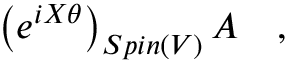Convert formula to latex. <formula><loc_0><loc_0><loc_500><loc_500>\left ( e ^ { i X \theta } \right ) _ { S p i n ( V ) } A \quad ,</formula> 